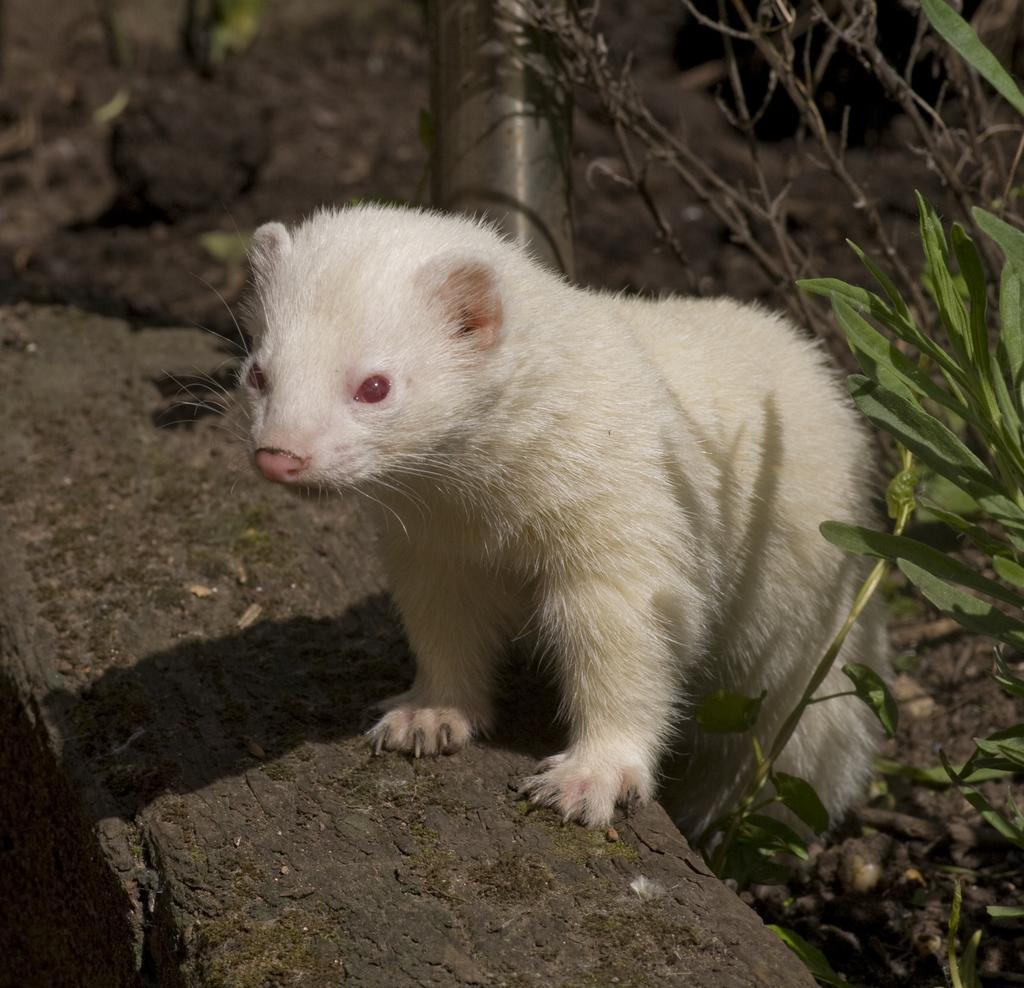In one or two sentences, can you explain what this image depicts? In this image there is a ferret, a pole, few plants and some sand particles on the ground. 